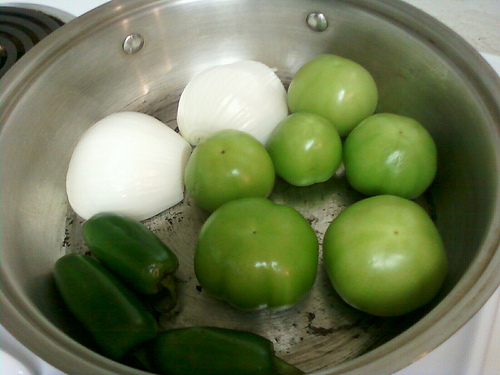<image>
Is there a sliced onion on the tabletop? No. The sliced onion is not positioned on the tabletop. They may be near each other, but the sliced onion is not supported by or resting on top of the tabletop. 